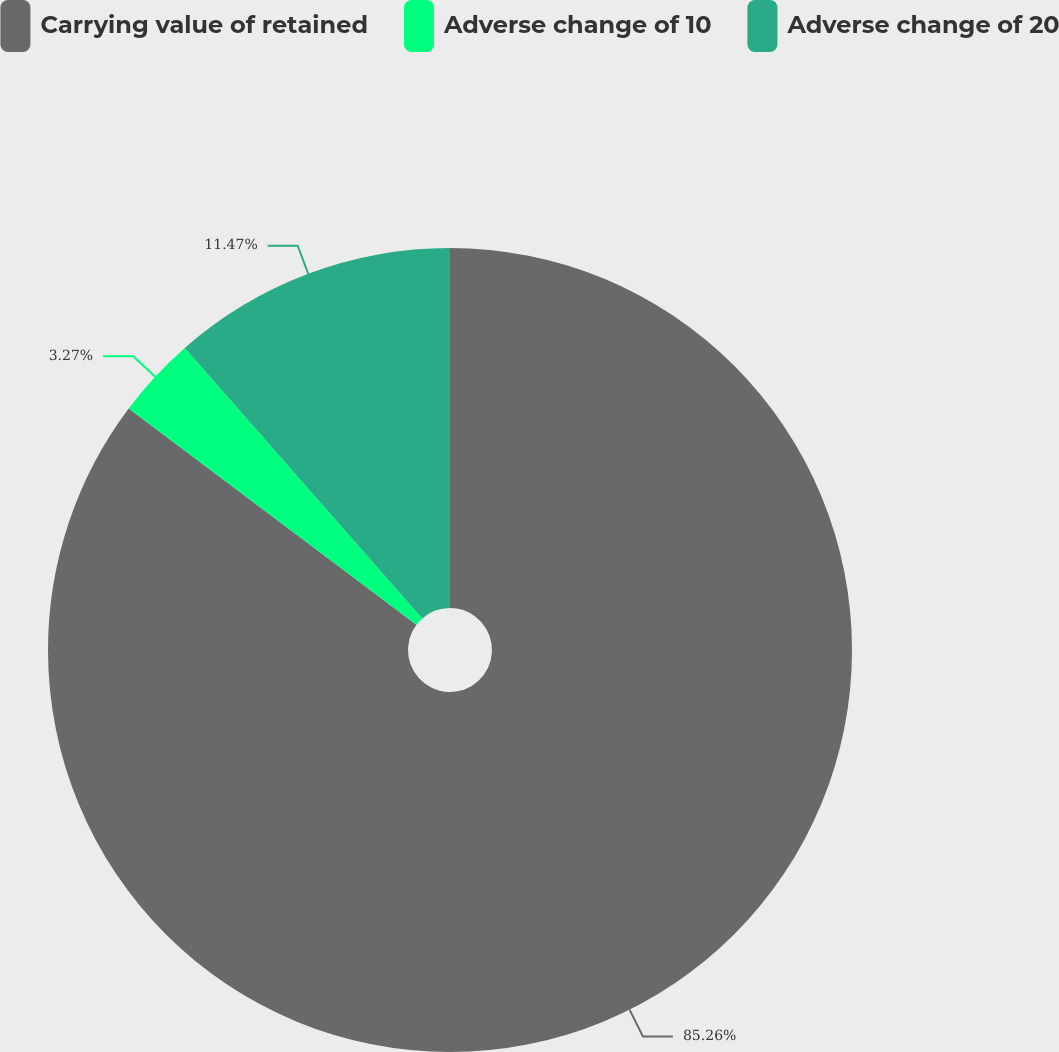Convert chart to OTSL. <chart><loc_0><loc_0><loc_500><loc_500><pie_chart><fcel>Carrying value of retained<fcel>Adverse change of 10<fcel>Adverse change of 20<nl><fcel>85.27%<fcel>3.27%<fcel>11.47%<nl></chart> 